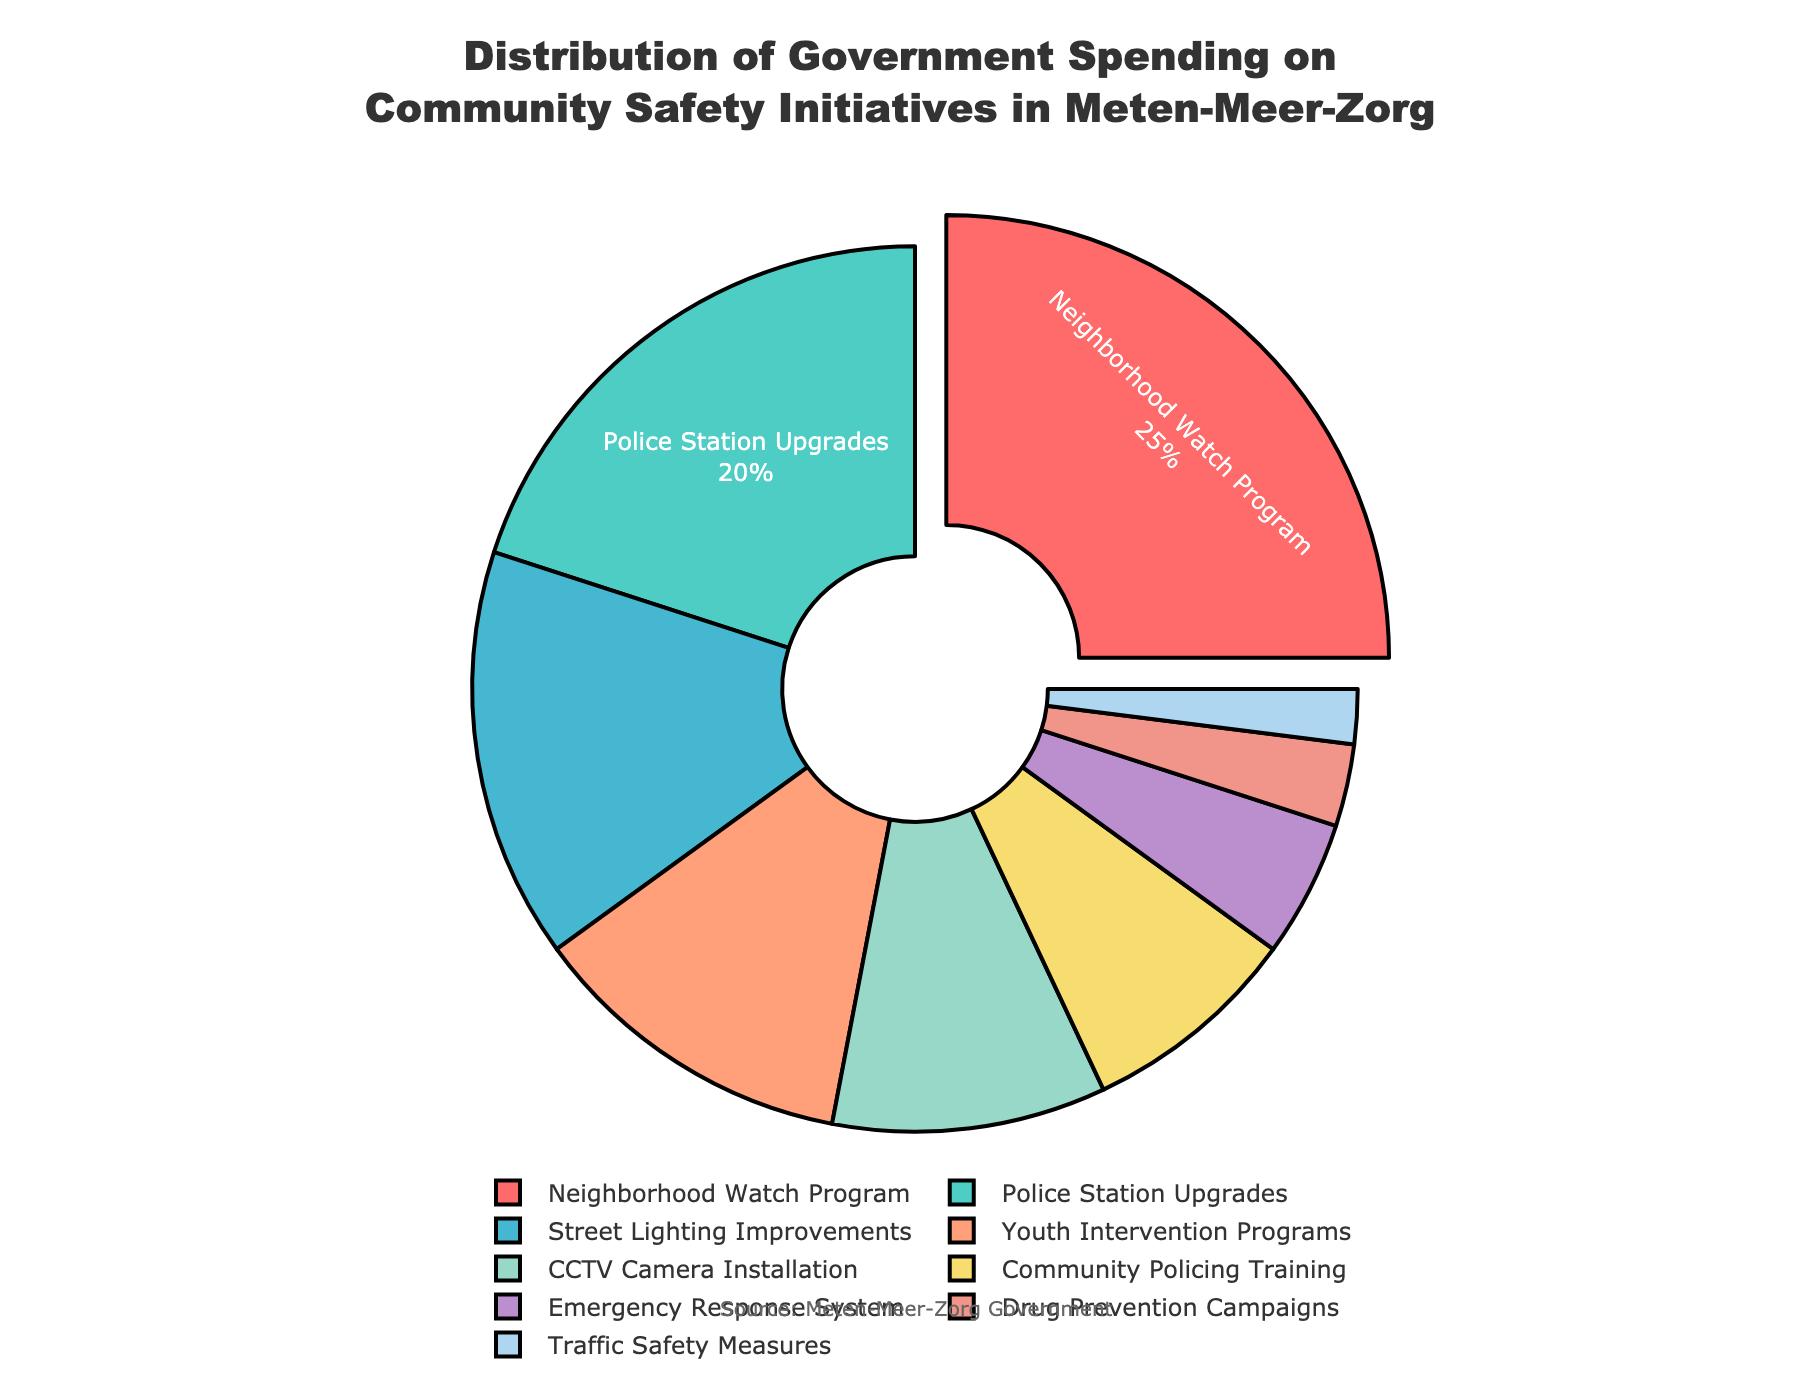Which community safety initiative has the highest percentage of government spending? The neighborhood watch program has the highest percentage. This is evident from the figure as it has the largest slice of the pie chart with 25%.
Answer: Neighborhood Watch Program What is the combined percentage of government spending on Police Station Upgrades, Youth Intervention Programs, and Traffic Safety Measures? To find the combined percentage, add the percentages of these three initiatives. Police Station Upgrades is 20%, Youth Intervention Programs is 12%, and Traffic Safety Measures is 2%. So, 20% + 12% + 2% = 34%.
Answer: 34% How much more is spent on Street Lighting Improvements compared to Drug Prevention Campaigns? Street Lighting Improvements accounts for 15%, while Drug Prevention Campaigns account for 3%. The difference is 15% - 3% = 12%.
Answer: 12% Which initiative has a share that is pulled out from the rest of the pie chart, and what is its percentage? The Neighborhood Watch Program is the only initiative that has its slice pulled out from the pie chart, and it represents 25% of the government spending.
Answer: Neighborhood Watch Program, 25% Is the spending on Community Policing Training greater than or equal to the spending on Emergency Response System? The government spends 8% on Community Policing Training and 5% on Emergency Response System. Since 8% is greater than 5%, the spending on Community Policing Training is greater.
Answer: Greater Which initiative is represented by a yellow slice, and what is its percentage? The Street Lighting Improvements initiative is represented by a yellow slice, and its percentage is 15%.
Answer: Street Lighting Improvements, 15% Rank the initiatives in descending order of their government spending percentages. Arranging the initiatives by their decreasing percentages gives: Neighborhood Watch Program (25%), Police Station Upgrades (20%), Street Lighting Improvements (15%), Youth Intervention Programs (12%), CCTV Camera Installation (10%), Community Policing Training (8%), Emergency Response System (5%), Drug Prevention Campaigns (3%), and Traffic Safety Measures (2%).
Answer: Neighborhood Watch Program, Police Station Upgrades, Street Lighting Improvements, Youth Intervention Programs, CCTV Camera Installation, Community Policing Training, Emergency Response System, Drug Prevention Campaigns, Traffic Safety Measures What percentage of total government spending is allocated to CCTV Camera Installation, Drug Prevention Campaigns, and Traffic Safety Measures combined? By summing the percentages: CCTV Camera Installation (10%) + Drug Prevention Campaigns (3%) + Traffic Safety Measures (2%) = 10% + 3% + 2% = 15%.
Answer: 15% If the spending on CCTV Camera Installation were increased by 5%, what would its new percentage be? The current percentage for CCTV Camera Installation is 10%. If increased by 5%, the new percentage would be 10% + 5% = 15%.
Answer: 15% 